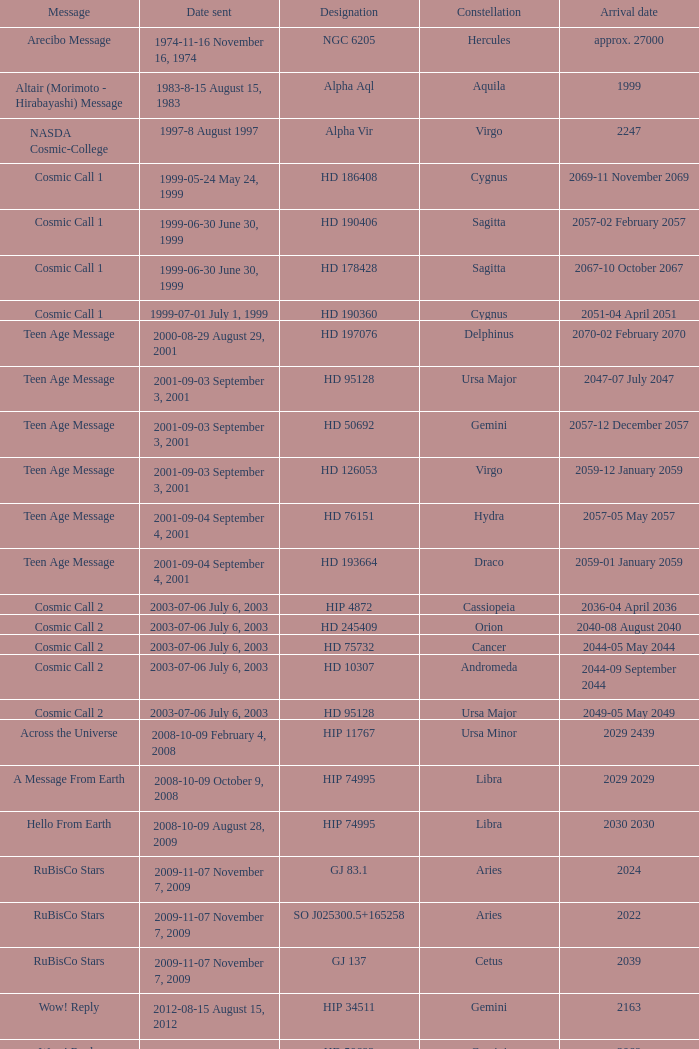What is the location of hip 4872? Cassiopeia. 